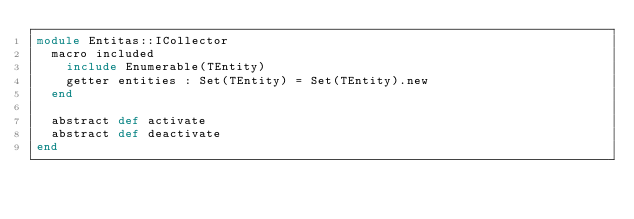Convert code to text. <code><loc_0><loc_0><loc_500><loc_500><_Crystal_>module Entitas::ICollector
  macro included
    include Enumerable(TEntity)
    getter entities : Set(TEntity) = Set(TEntity).new
  end

  abstract def activate
  abstract def deactivate
end
</code> 